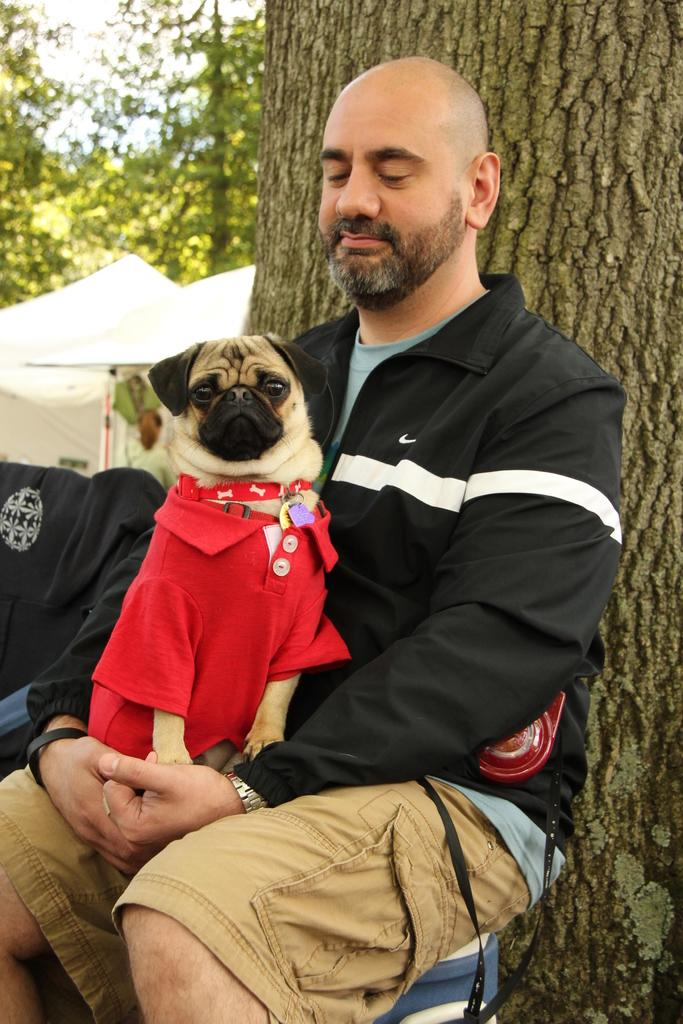What is the person in the image doing? The person is sitting in the image. What is the person holding in the image? The person is holding a dog in the image. What is the dog wearing? The dog is wearing a red t-shirt. What can be seen in the background of the image? There are tents and trees visible in the background of the image. What type of shoes is the dog wearing in the image? The dog is not wearing shoes in the image; it is wearing a red t-shirt. Can you tell me how many pears are visible in the image? There are no pears present in the image. 